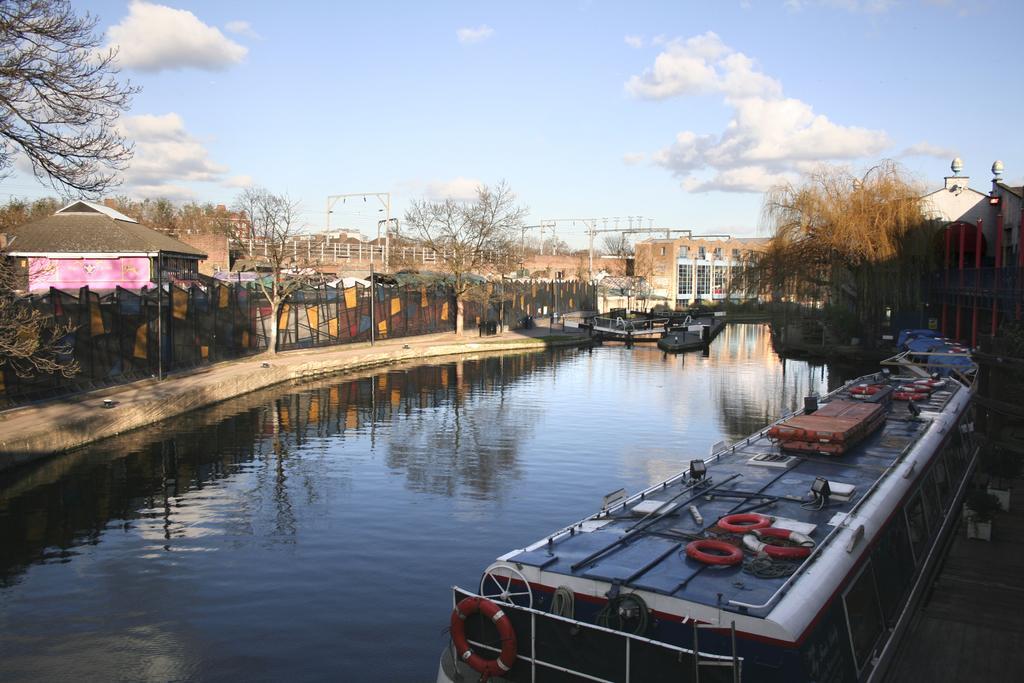In one or two sentences, can you explain what this image depicts? In this picture there is a canal on the right side of the image and there is water in the center of the image, there is boundary on the left side of the image and there are houses and trees in the background area of the image. 